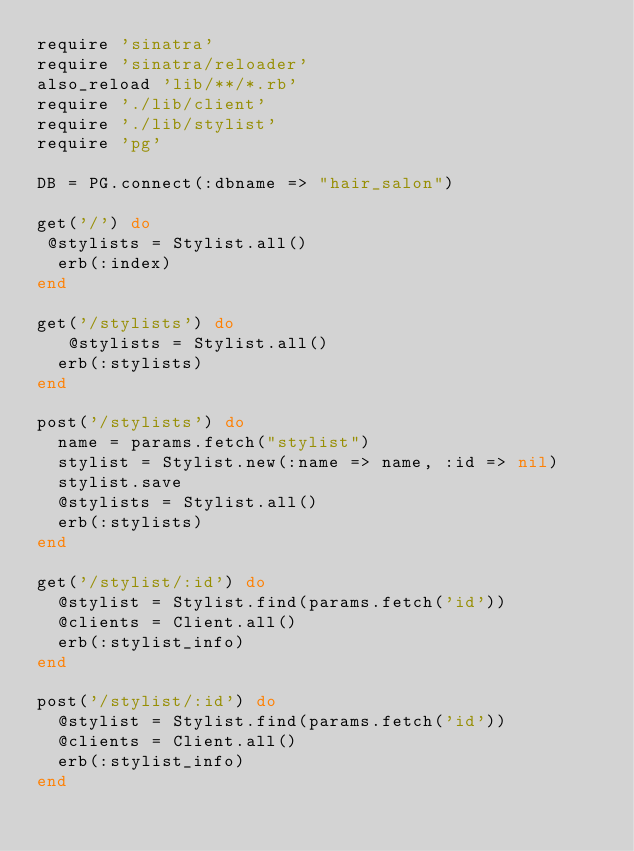<code> <loc_0><loc_0><loc_500><loc_500><_Ruby_>require 'sinatra'
require 'sinatra/reloader'
also_reload 'lib/**/*.rb'
require './lib/client'
require './lib/stylist'
require 'pg'

DB = PG.connect(:dbname => "hair_salon")

get('/') do 
 @stylists = Stylist.all()
  erb(:index)
end

get('/stylists') do 
   @stylists = Stylist.all()
  erb(:stylists)
end

post('/stylists') do
	name = params.fetch("stylist")
  stylist = Stylist.new(:name => name, :id => nil)
	stylist.save
	@stylists = Stylist.all()
	erb(:stylists)
end

get('/stylist/:id') do
	@stylist = Stylist.find(params.fetch('id'))
  @clients = Client.all()
	erb(:stylist_info)
end

post('/stylist/:id') do
	@stylist = Stylist.find(params.fetch('id'))
  @clients = Client.all()
	erb(:stylist_info)
end</code> 